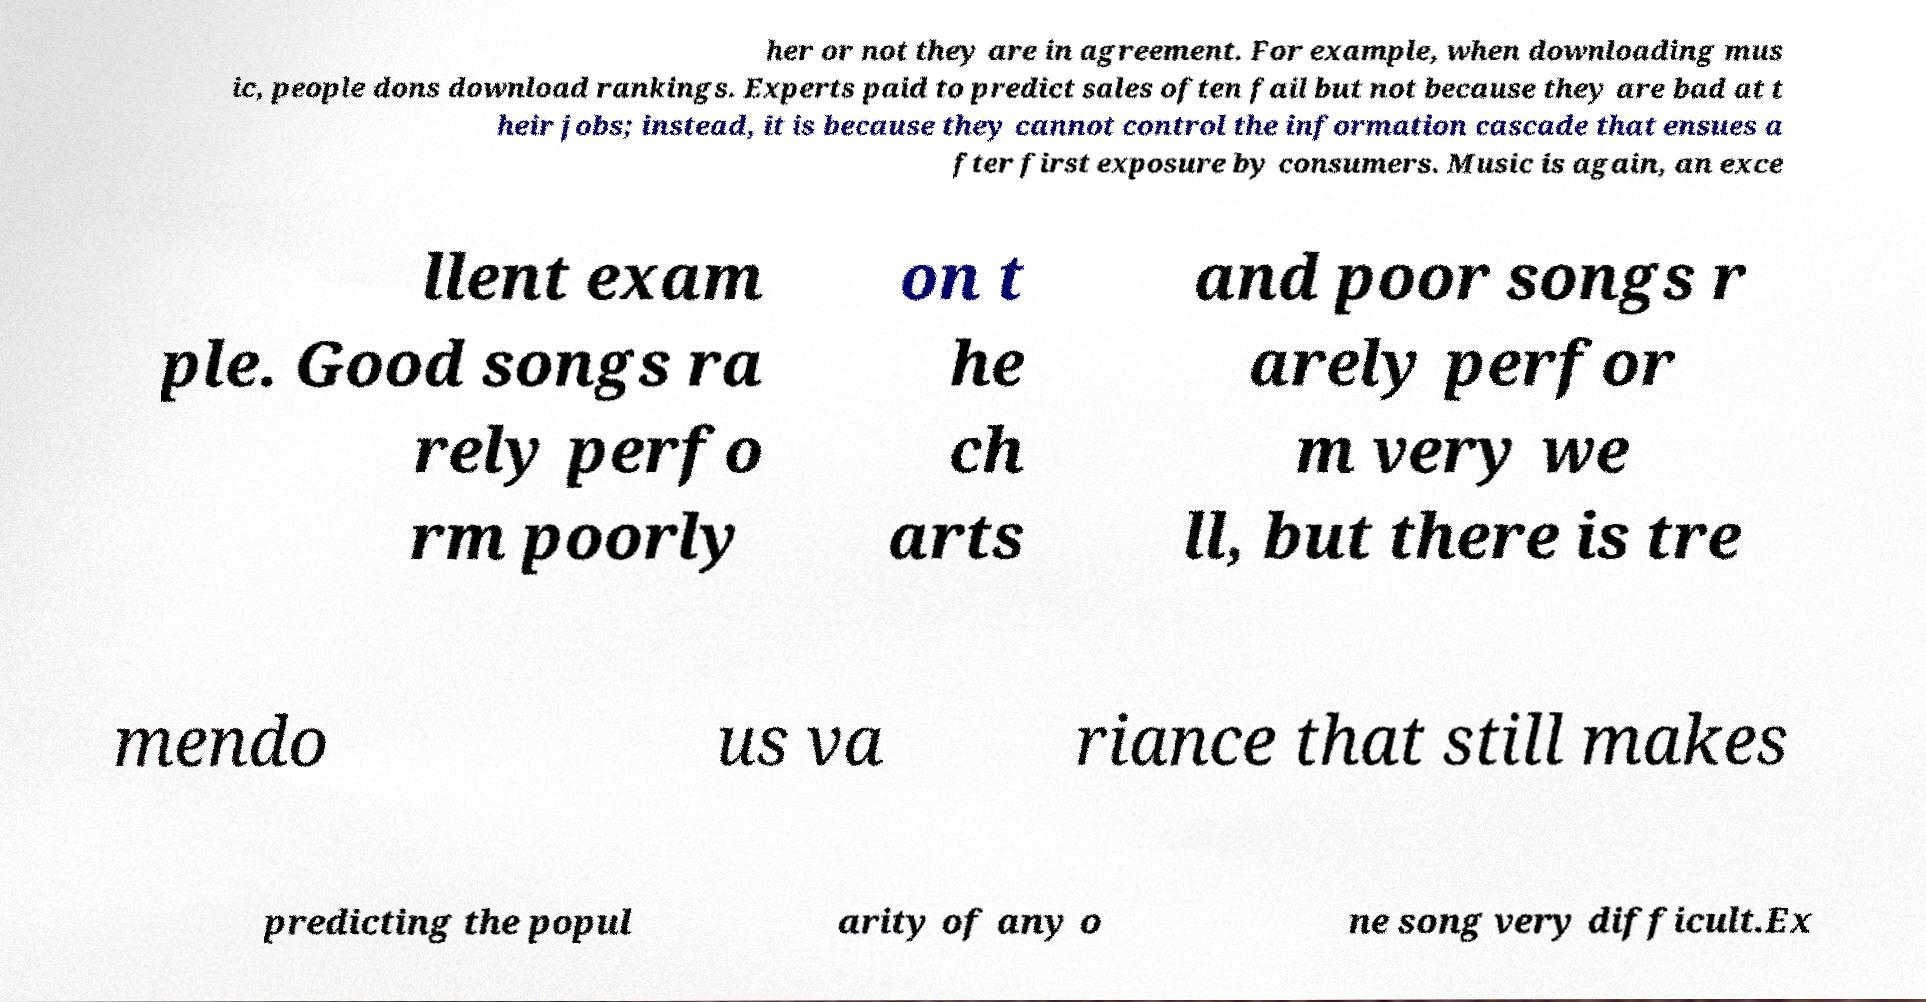Can you accurately transcribe the text from the provided image for me? her or not they are in agreement. For example, when downloading mus ic, people dons download rankings. Experts paid to predict sales often fail but not because they are bad at t heir jobs; instead, it is because they cannot control the information cascade that ensues a fter first exposure by consumers. Music is again, an exce llent exam ple. Good songs ra rely perfo rm poorly on t he ch arts and poor songs r arely perfor m very we ll, but there is tre mendo us va riance that still makes predicting the popul arity of any o ne song very difficult.Ex 